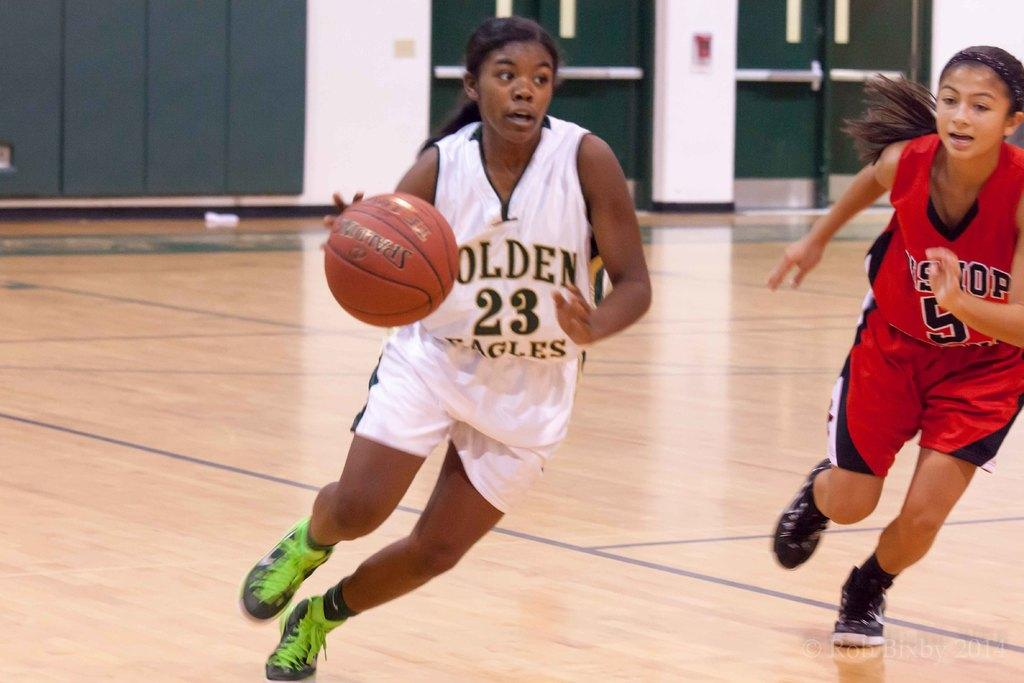<image>
Present a compact description of the photo's key features. A girl dribbling a basketball wears the number 23 for the golden eagles. 